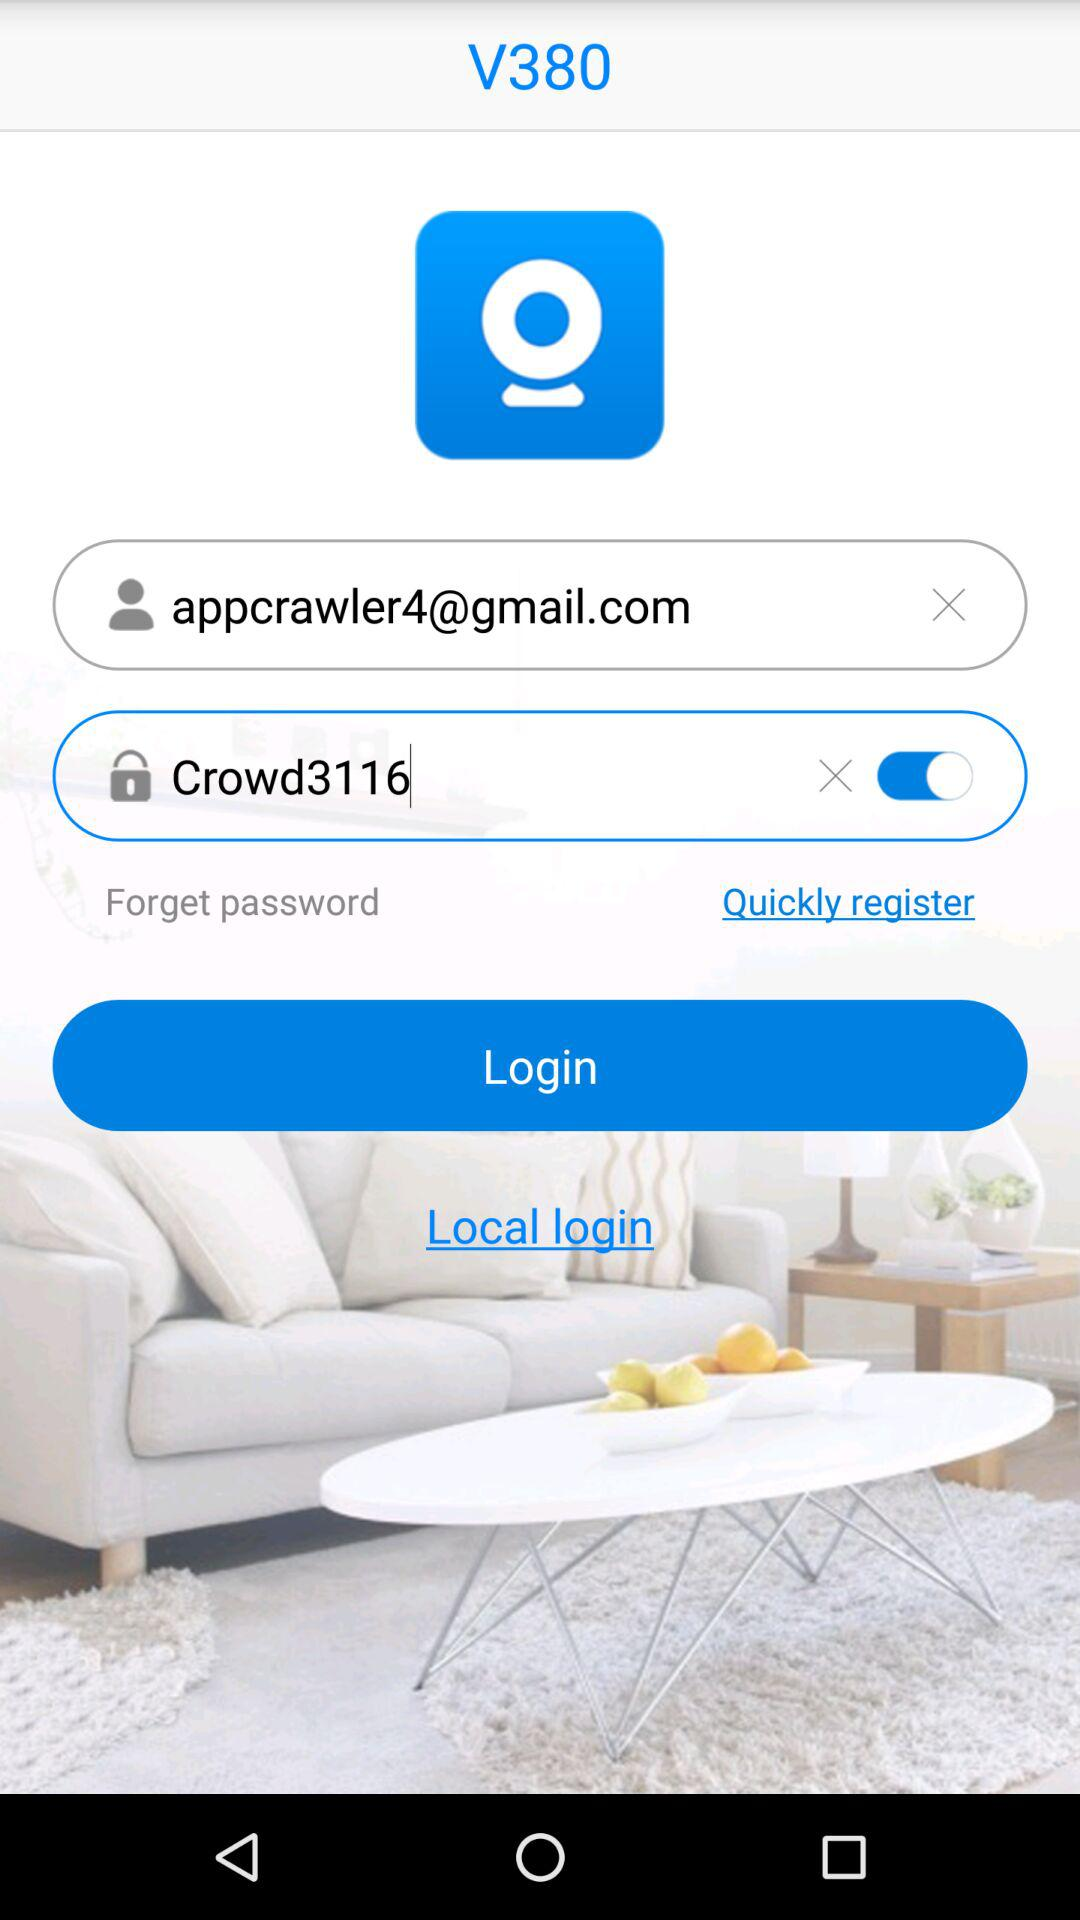What is the password? The password is Crowd3116. 